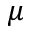<formula> <loc_0><loc_0><loc_500><loc_500>\mu</formula> 